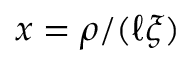Convert formula to latex. <formula><loc_0><loc_0><loc_500><loc_500>x = \rho / ( \ell \xi )</formula> 